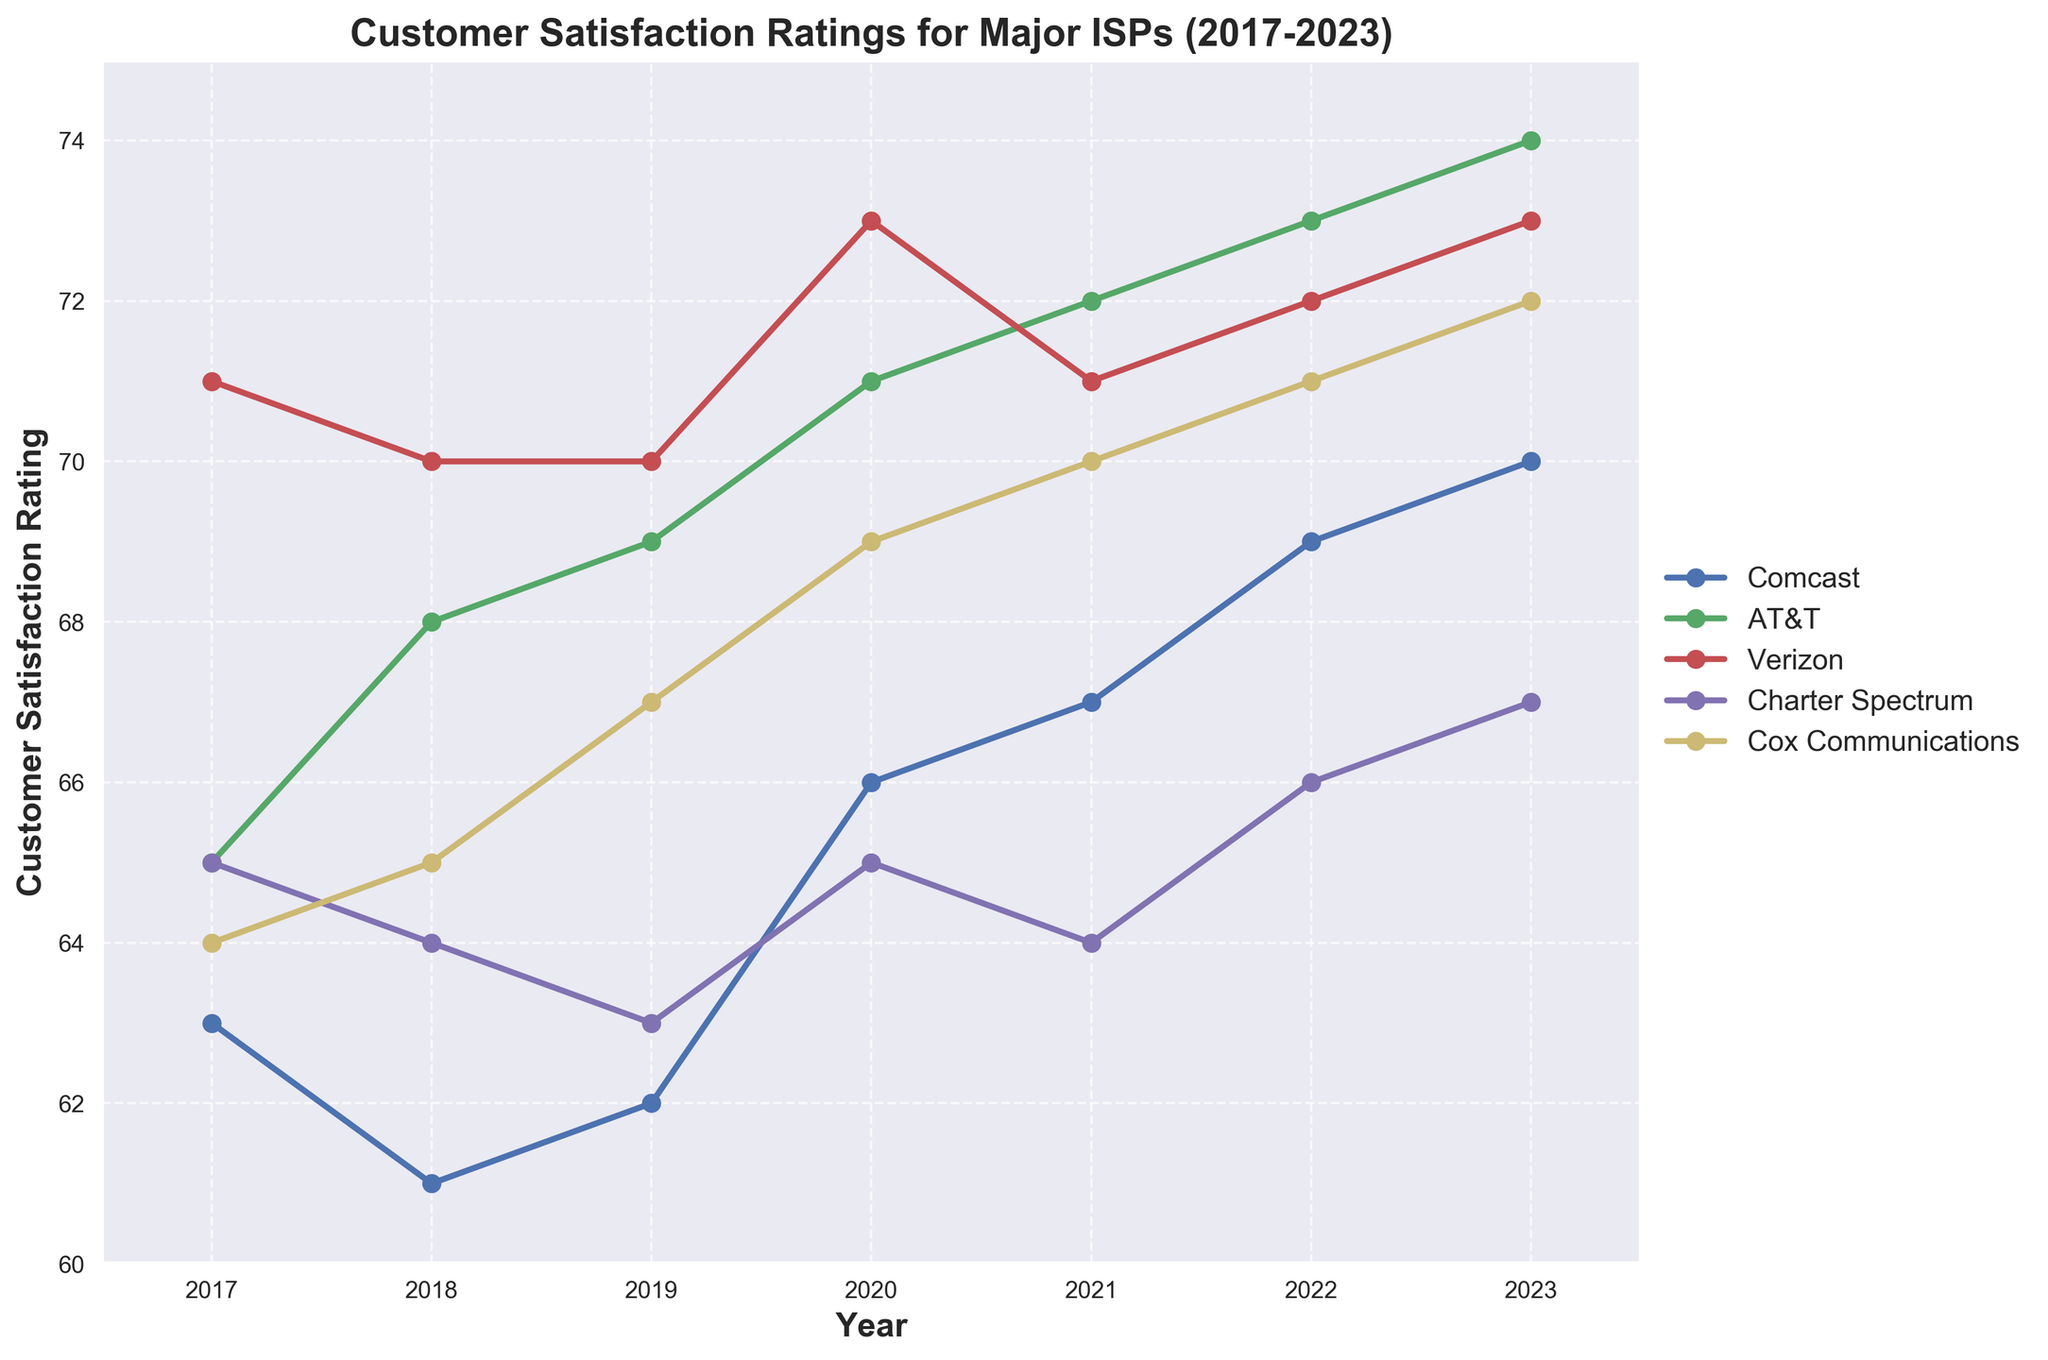what year did Verizon achieve its highest customer satisfaction rating? To find Verizon's highest customer satisfaction rating, look at Verizon's line and identify the peak point. Then, check the corresponding year. The highest rating for Verizon is 73, which occurred in 2020 and 2023.
Answer: 2020 and 2023 Which ISP has the highest overall customer satisfaction rating in 2023? Look at each ISP's rating for the year 2023 and find the one with the highest value. Charter Spectrum has a rating of 67, Cox Communications has a rating of 72, AT&T has a rating of 74, Verizon has a rating of 73, and Comcast has a rating of 70. The highest value is 74 by AT&T.
Answer: AT&T Between which two consecutive years did Comcast experience the largest increase in customer satisfaction rating? Compare the year-over-year differences for Comcast's ratings. From 2017 to 2018, the change is -2; from 2018 to 2019, it's +1; from 2019 to 2020, it's +4; from 2020 to 2021, it's +1; from 2021 to 2022, it's +2; from 2022 to 2023, it's +1. The largest increase of +4 happened between 2019 and 2020.
Answer: Between 2019 and 2020 What's the average customer satisfaction rating for Cox Communications from 2017 to 2023? Add up the ratings for Cox Communications from 2017 to 2023 and divide by the number of years (7). The values are 64, 65, 67, 69, 70, 71, and 72. Sum = 478. Average = 478 / 7 = 68.29.
Answer: 68.29 Which ISP had the most consistent (least variation in) customer satisfaction ratings over the period from 2017 to 2023? To determine consistency, assess the variation in ratings for each ISP. Calculate the range (max - min) for each ISP: Comcast (70 - 61 = 9), AT&T (74 - 65 = 9), Verizon (73 - 70 = 3), Charter Spectrum (67 - 63 = 4), Cox Communications (72 - 64 = 8). Verizon has the smallest range.
Answer: Verizon What is the combined customer satisfaction rating for Charter Spectrum in 2019 and Cox Communications in 2021? Add the ratings for Charter Spectrum in 2019 (63) and Cox Communications in 2021 (70). Sum = 63 + 70 = 133.
Answer: 133 How many ISPs had higher customer satisfaction ratings in 2023 compared to 2017? Compare the ratings for each ISP in 2017 and 2023. Comcast (70 > 63), AT&T (74 > 65), Verizon (73 > 71), Charter Spectrum (67 > 65), Cox Communications (72 > 64). All five ISPs had higher ratings in 2023 compared to 2017.
Answer: 5 During which year did all ISPs have their customer satisfaction rating between 60 and 75? Check each year's ratings to ensure all values fall between 60 and 75: 2017, 2018, 2019, 2020, 2021, 2022, and 2023. All years fall within this range.
Answer: All years Which ISP showed the most significant improvement in customer satisfaction rating from 2017 to 2023? Subtract the 2017 rating from the 2023 rating for each ISP: Comcast (70 - 63 = 7), AT&T (74 - 65 = 9), Verizon (73 - 71 = 2), Charter Spectrum (67 - 65 = 2), Cox Communications (72 - 64 = 8). AT&T had the most significant improvement of 9 points.
Answer: AT&T 